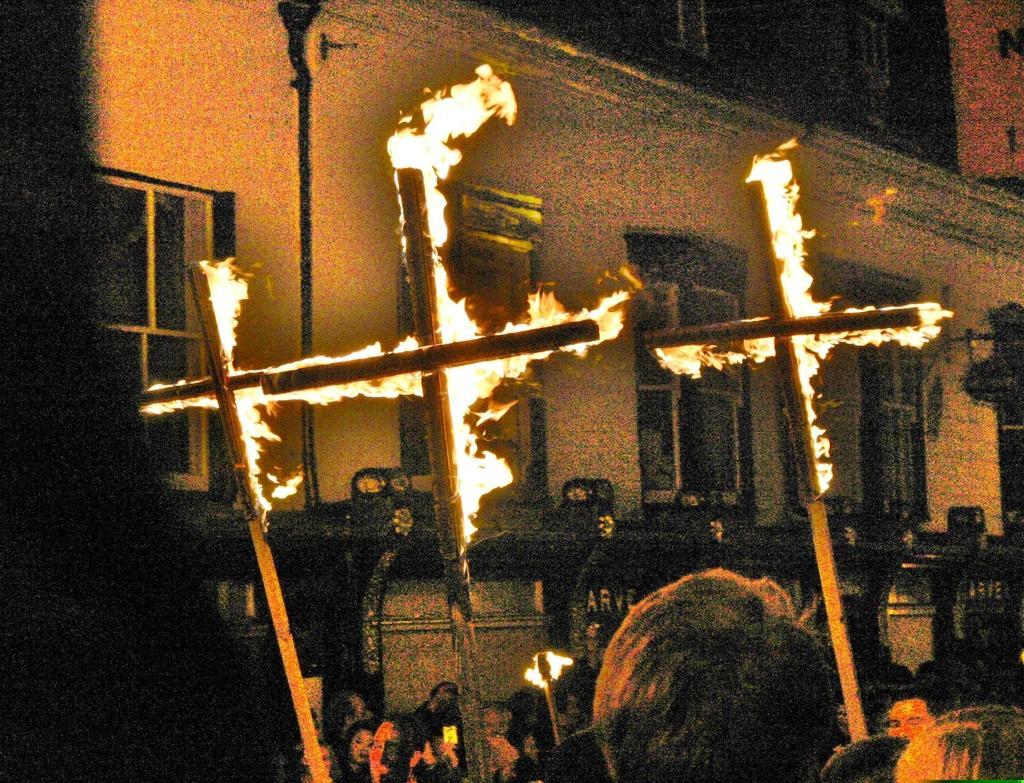Please provide a concise description of this image. In this image, I can see the sticks with the fire. At the bottom of the image, I can see the heads of the people. In the background, I can see a building with windows and there is a pole. 